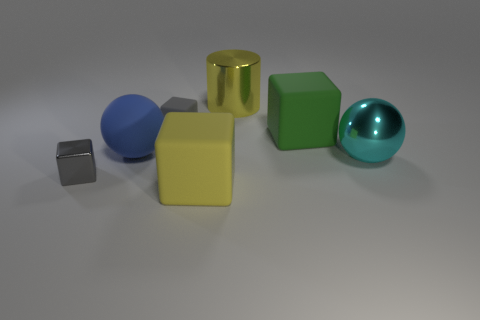There is a large green rubber object; are there any blue rubber spheres in front of it?
Provide a short and direct response. Yes. There is a green matte thing; is its size the same as the cyan thing that is in front of the blue rubber thing?
Provide a succinct answer. Yes. What number of other objects are there of the same material as the large yellow cylinder?
Provide a short and direct response. 2. What is the shape of the object that is behind the green matte cube and to the left of the big yellow cylinder?
Ensure brevity in your answer.  Cube. There is a ball to the right of the blue rubber thing; is its size the same as the gray block that is behind the big blue rubber sphere?
Give a very brief answer. No. What is the shape of the large yellow object that is made of the same material as the cyan thing?
Your answer should be very brief. Cylinder. Are there any other things that are the same shape as the yellow metallic thing?
Offer a terse response. No. There is a large object that is left of the cube that is in front of the small cube that is in front of the small matte cube; what color is it?
Make the answer very short. Blue. Is the number of objects that are on the right side of the big blue matte sphere less than the number of things to the left of the large metal ball?
Offer a terse response. Yes. Is the shape of the large green thing the same as the gray metallic object?
Offer a terse response. Yes. 